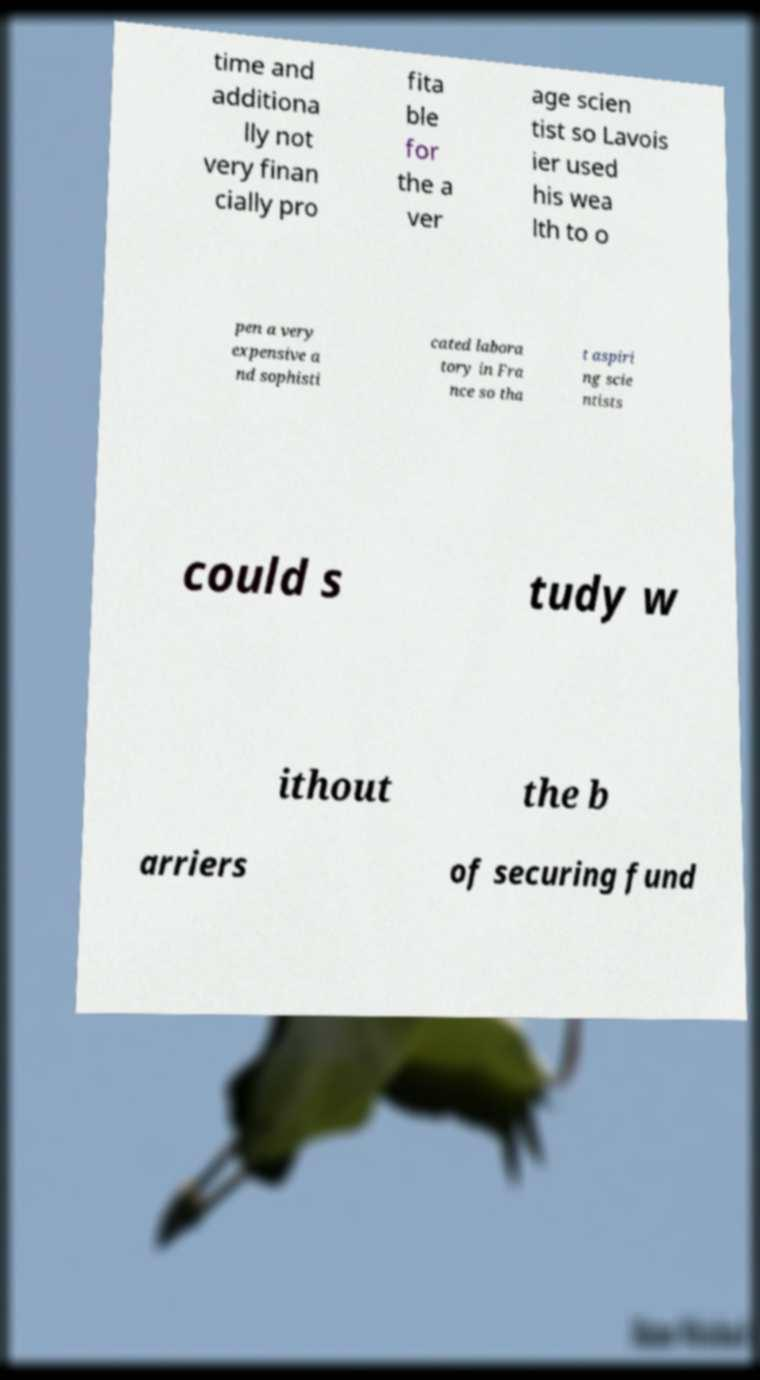Please identify and transcribe the text found in this image. time and additiona lly not very finan cially pro fita ble for the a ver age scien tist so Lavois ier used his wea lth to o pen a very expensive a nd sophisti cated labora tory in Fra nce so tha t aspiri ng scie ntists could s tudy w ithout the b arriers of securing fund 